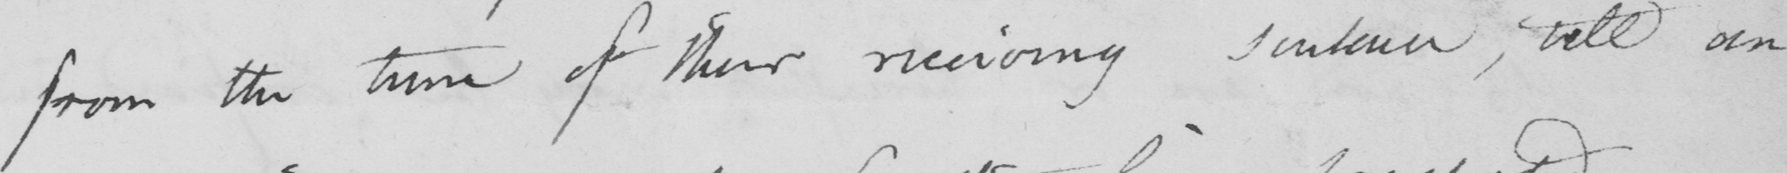Transcribe the text shown in this historical manuscript line. from the time of their receiving sentence, till an 